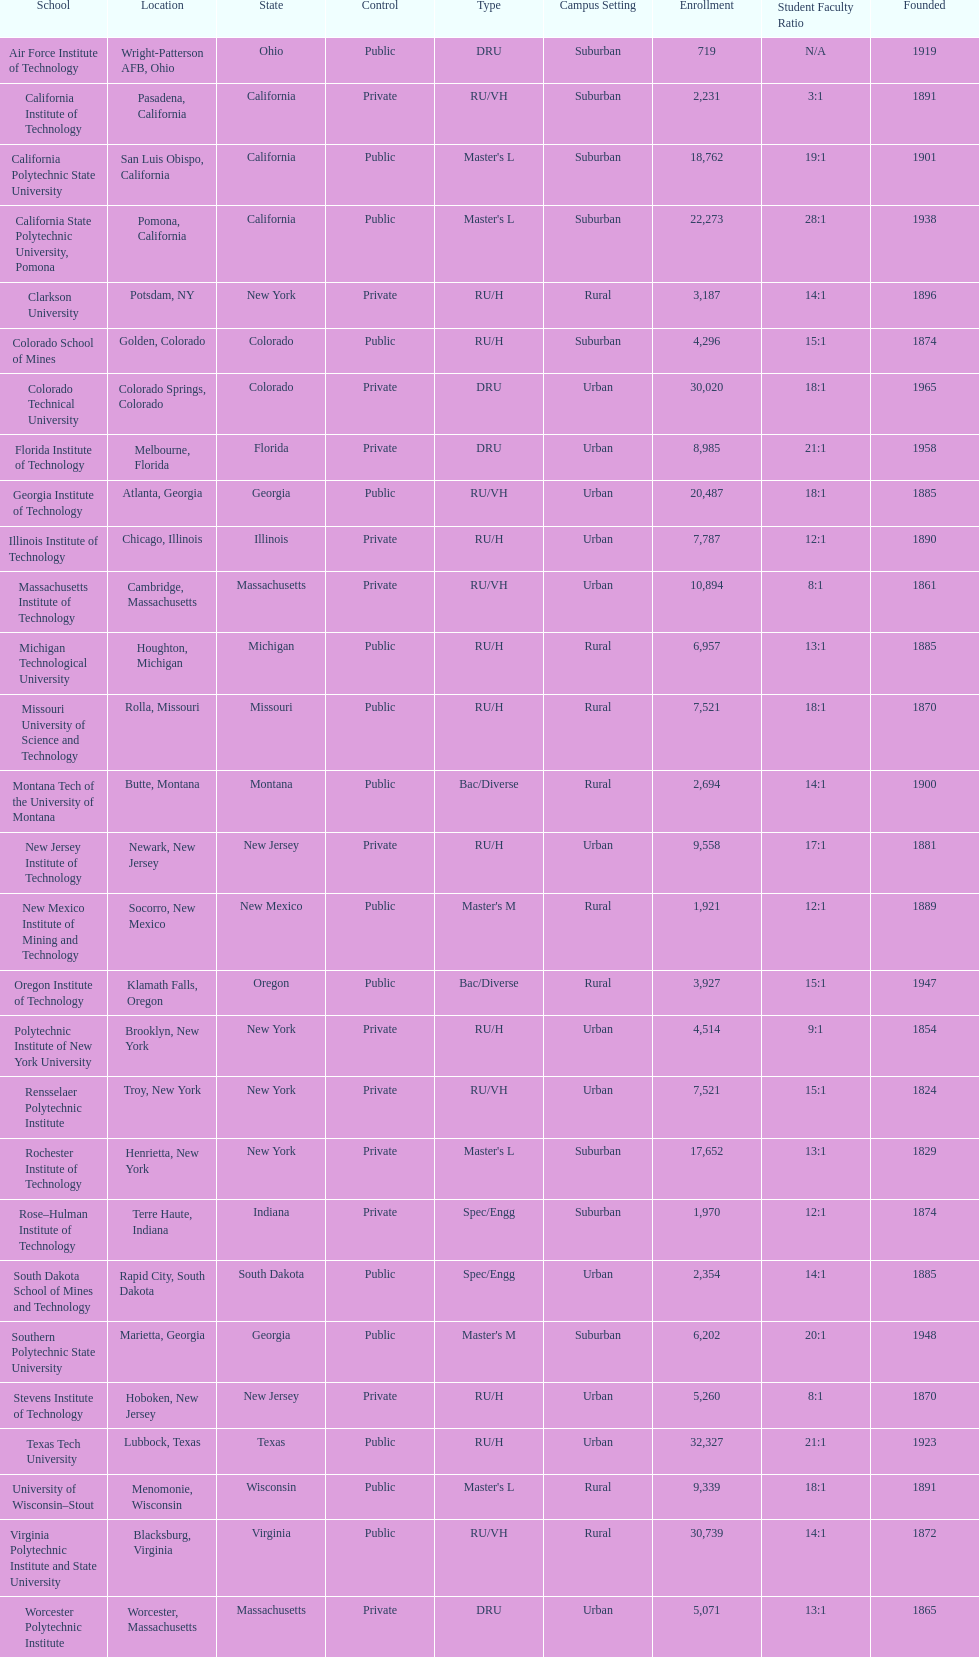Which of the universities was founded first? Rensselaer Polytechnic Institute. 